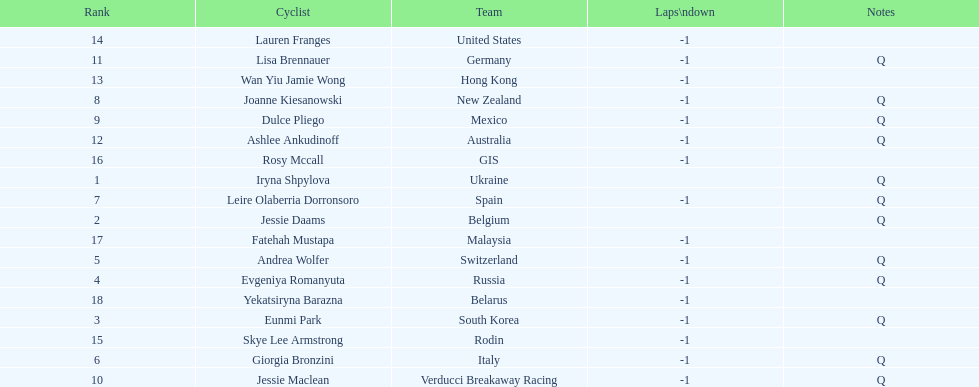Who is the last cyclist listed? Yekatsiryna Barazna. 